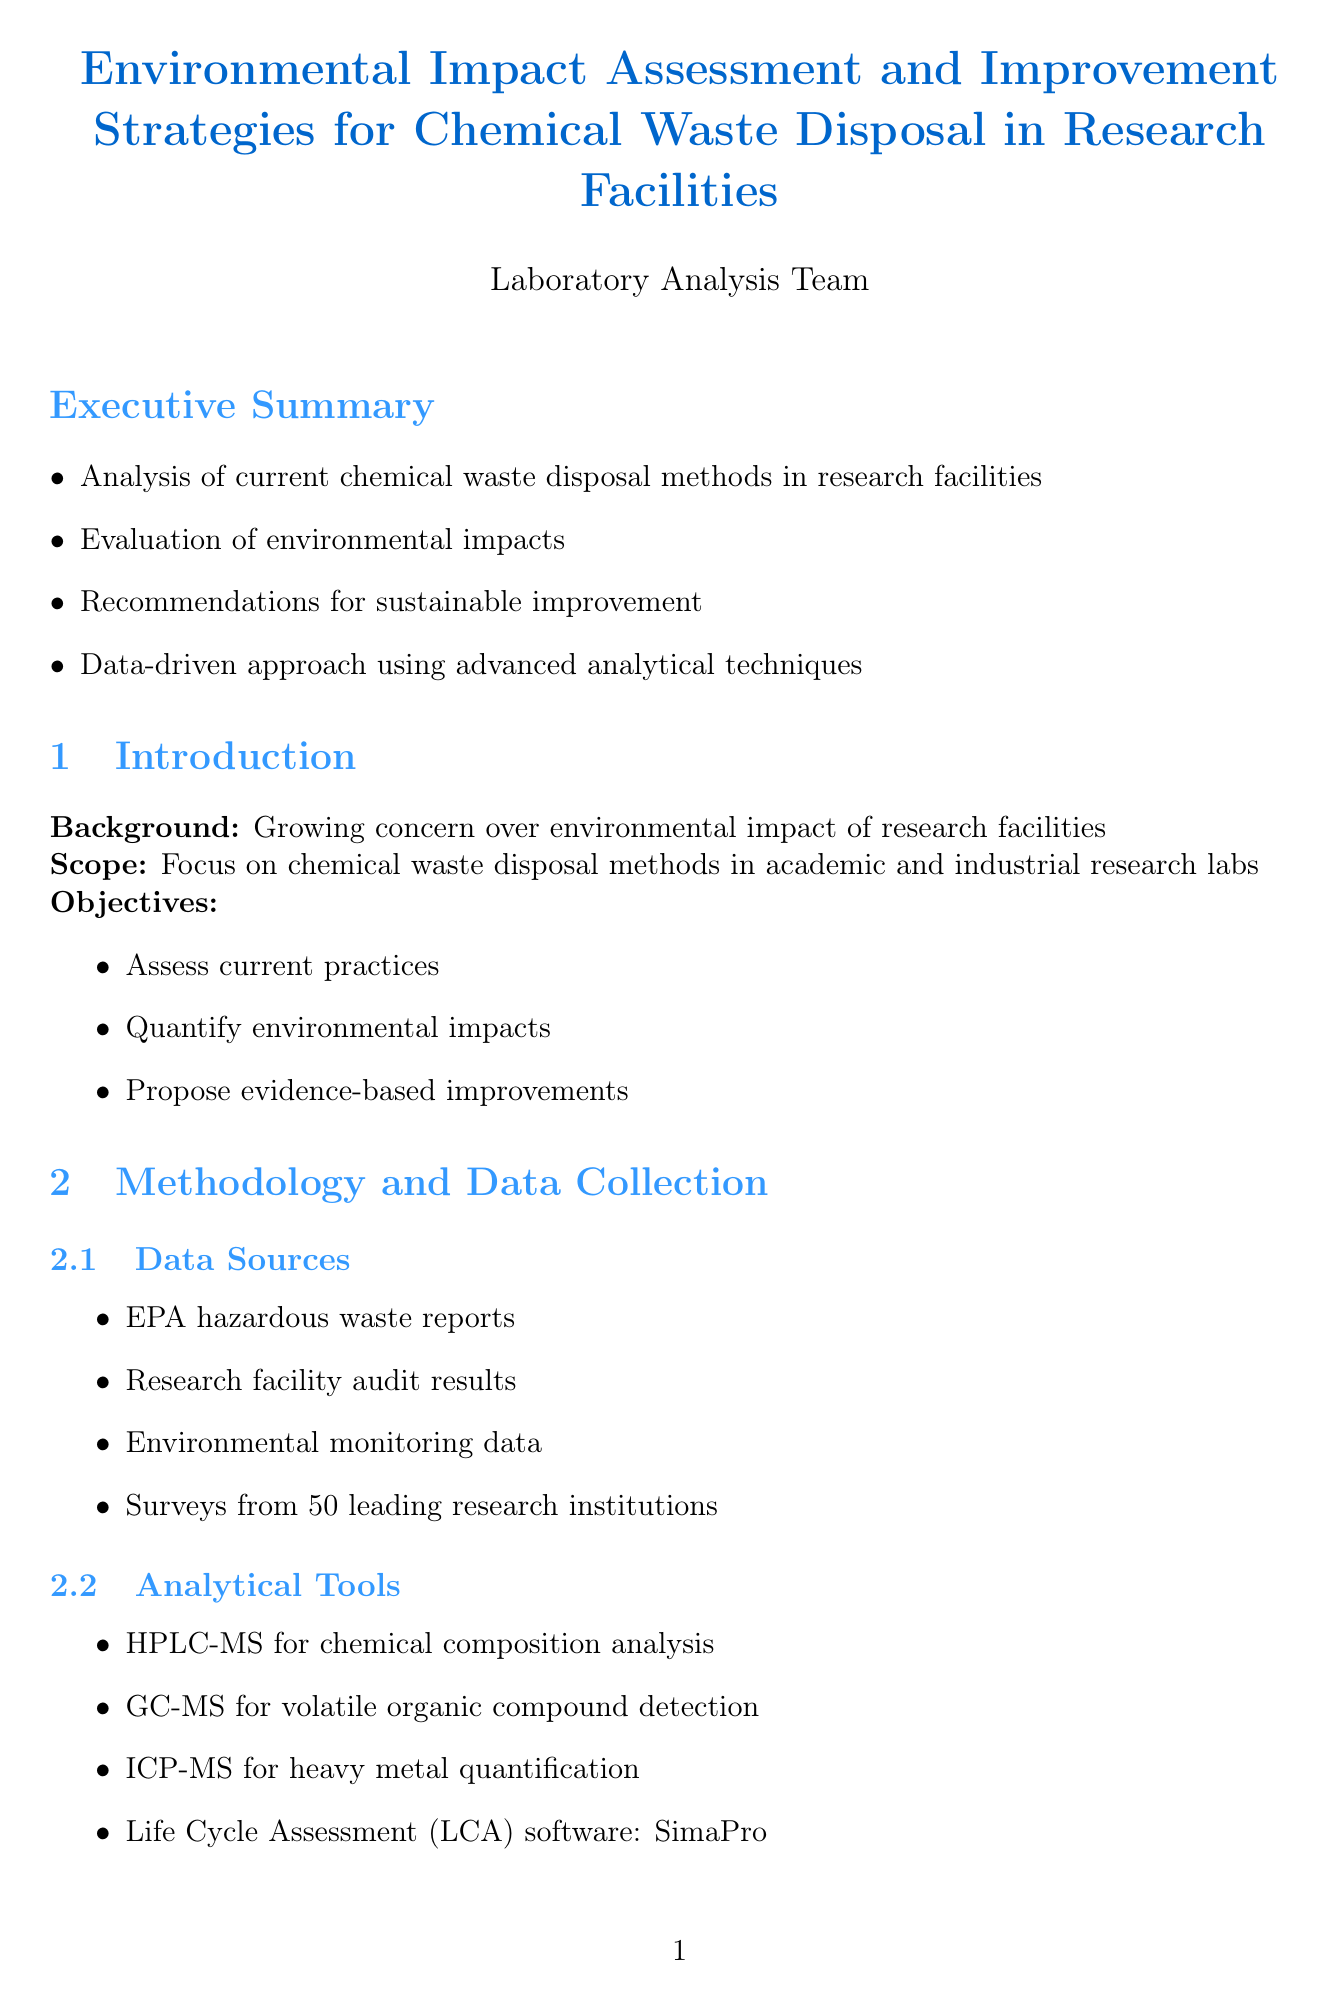what is the title of the report? The title of the report is mentioned at the beginning of the document.
Answer: Environmental Impact Assessment and Improvement Strategies for Chemical Waste Disposal in Research Facilities how many research institutions were surveyed? The document states the number of institutions from which data was collected.
Answer: 50 what percentage of facilities use incineration for waste disposal? The report lists the prevalence of disposal methods in research facilities.
Answer: 65% what is the potential impact of implementing green chemistry principles? The recommendations section specifies the expected reduction in hazardous waste volume.
Answer: Up to 40% reduction in hazardous waste volume what is the outcome of the Green Labs Program at MIT? The case studies section provides specific outcomes of initiatives taken by research institutions.
Answer: 30% reduction in hazardous waste generation over 5 years what type of data analyzed air quality impacts? The environmental impact analysis includes various pollutants affecting air quality.
Answer: NOx, SOx, Particulate matter, Dioxins what is a recommendation for water contamination reduction? The recommendations section highlights strategies to address specific environmental issues.
Answer: Advanced wastewater treatment systems how much CO2e was saved by Novartis' solvent recycling program? The document provides specific financial and environmental results from case studies.
Answer: 750 metric tons of CO2e 